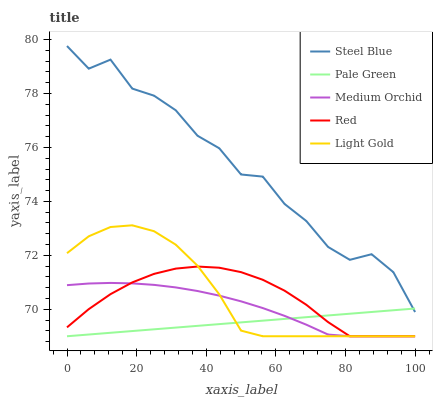Does Pale Green have the minimum area under the curve?
Answer yes or no. Yes. Does Steel Blue have the maximum area under the curve?
Answer yes or no. Yes. Does Light Gold have the minimum area under the curve?
Answer yes or no. No. Does Light Gold have the maximum area under the curve?
Answer yes or no. No. Is Pale Green the smoothest?
Answer yes or no. Yes. Is Steel Blue the roughest?
Answer yes or no. Yes. Is Light Gold the smoothest?
Answer yes or no. No. Is Light Gold the roughest?
Answer yes or no. No. Does Medium Orchid have the lowest value?
Answer yes or no. Yes. Does Steel Blue have the lowest value?
Answer yes or no. No. Does Steel Blue have the highest value?
Answer yes or no. Yes. Does Light Gold have the highest value?
Answer yes or no. No. Is Medium Orchid less than Steel Blue?
Answer yes or no. Yes. Is Steel Blue greater than Medium Orchid?
Answer yes or no. Yes. Does Pale Green intersect Medium Orchid?
Answer yes or no. Yes. Is Pale Green less than Medium Orchid?
Answer yes or no. No. Is Pale Green greater than Medium Orchid?
Answer yes or no. No. Does Medium Orchid intersect Steel Blue?
Answer yes or no. No. 